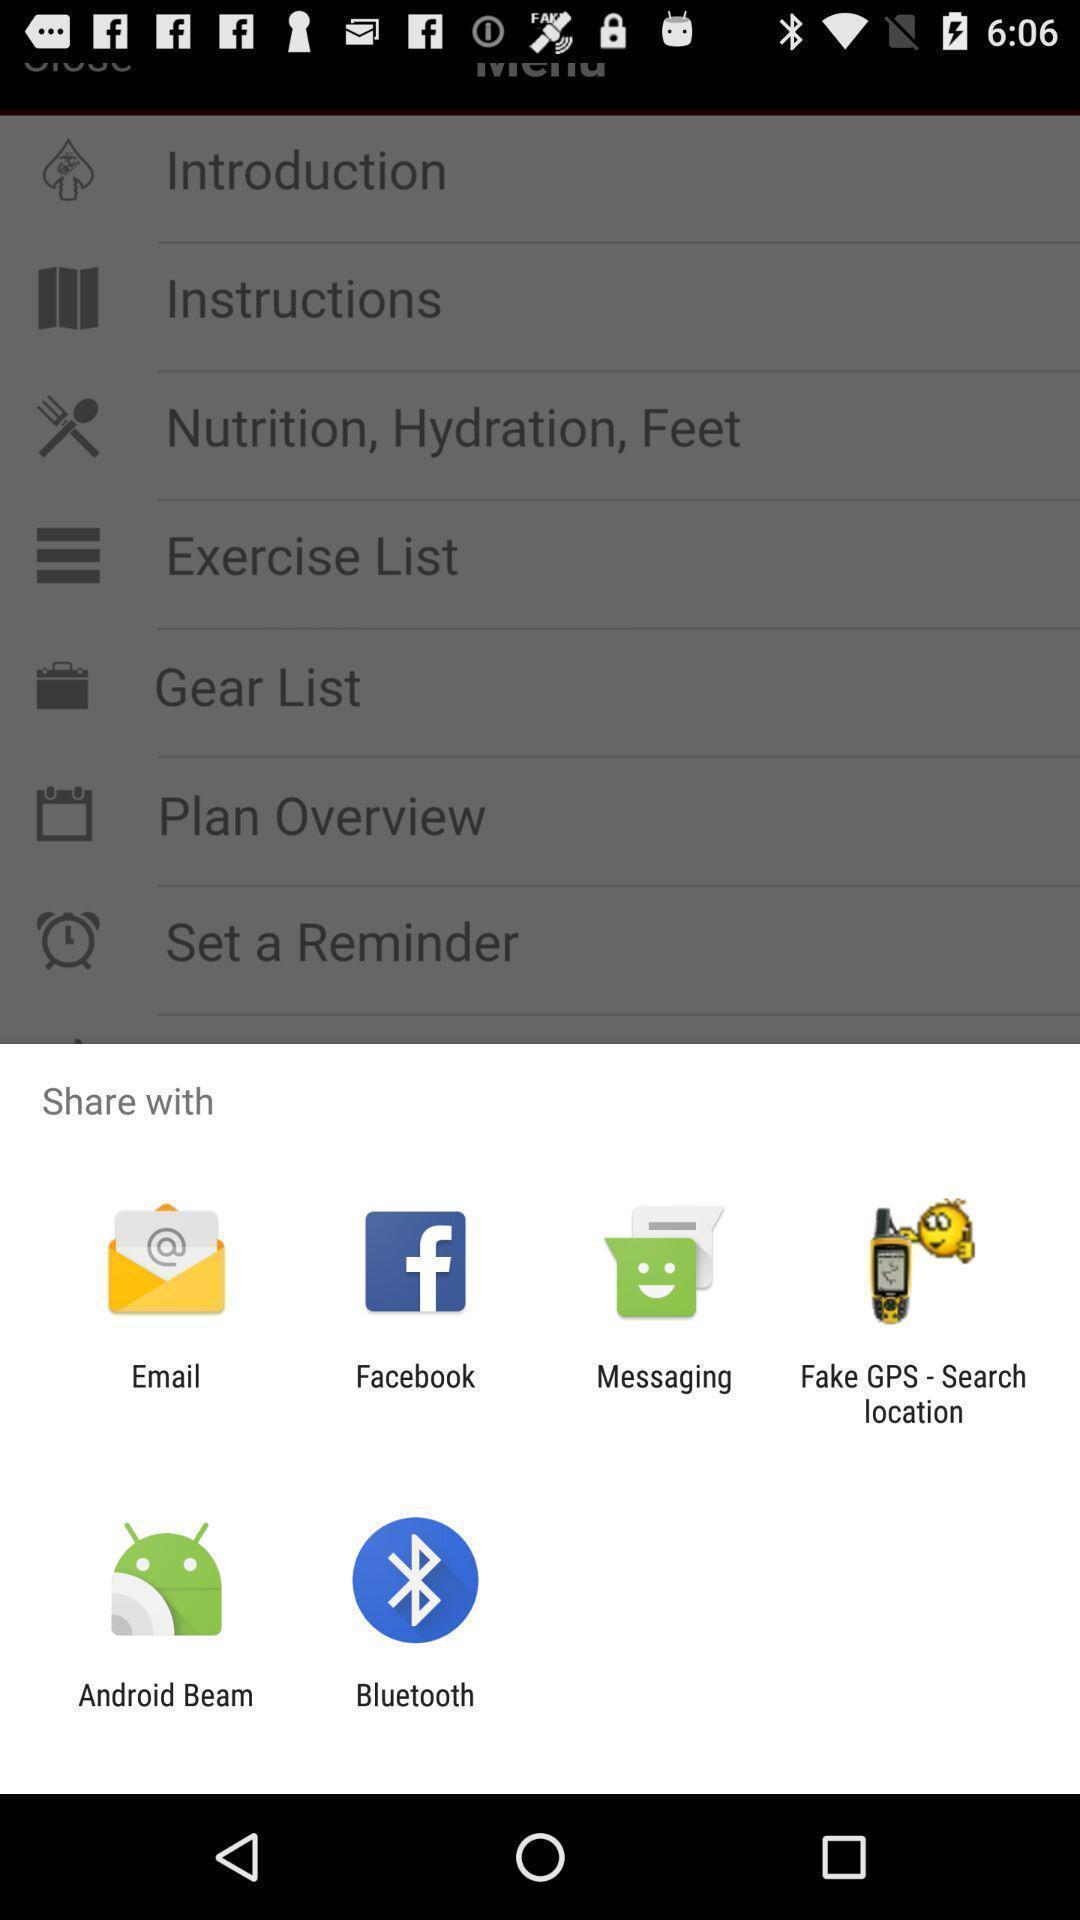Summarize the information in this screenshot. Popup to share with different options in the app. 